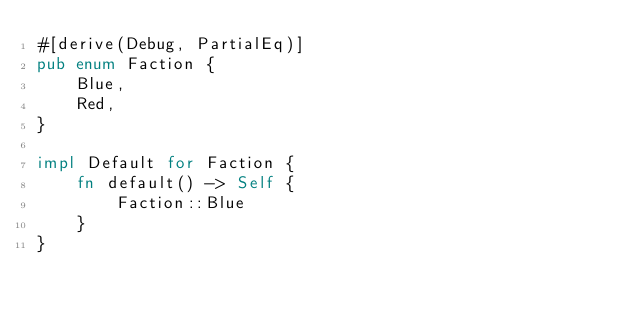<code> <loc_0><loc_0><loc_500><loc_500><_Rust_>#[derive(Debug, PartialEq)]
pub enum Faction {
    Blue,
    Red,
}

impl Default for Faction {
    fn default() -> Self {
        Faction::Blue
    }
}
</code> 